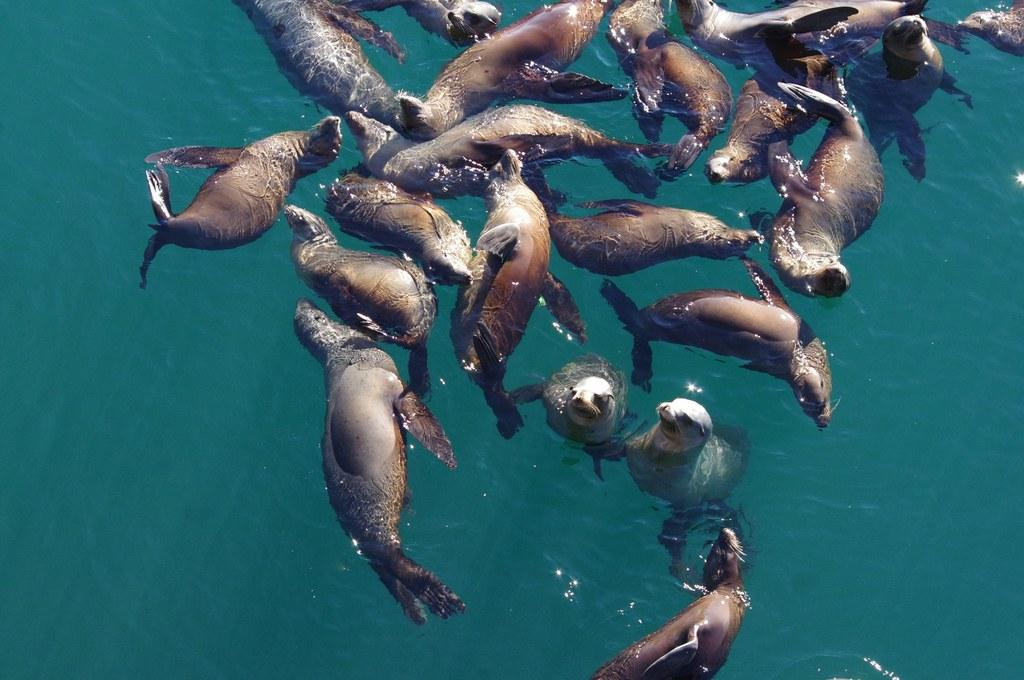What type of animals are in the image? There are sea lions in the image. Where are the sea lions located? The sea lions are in the water. What type of food can be seen in the image? There is no food present in the image; it features sea lions in the water. How many mice are visible in the image? There are no mice present in the image; it features sea lions in the water. 